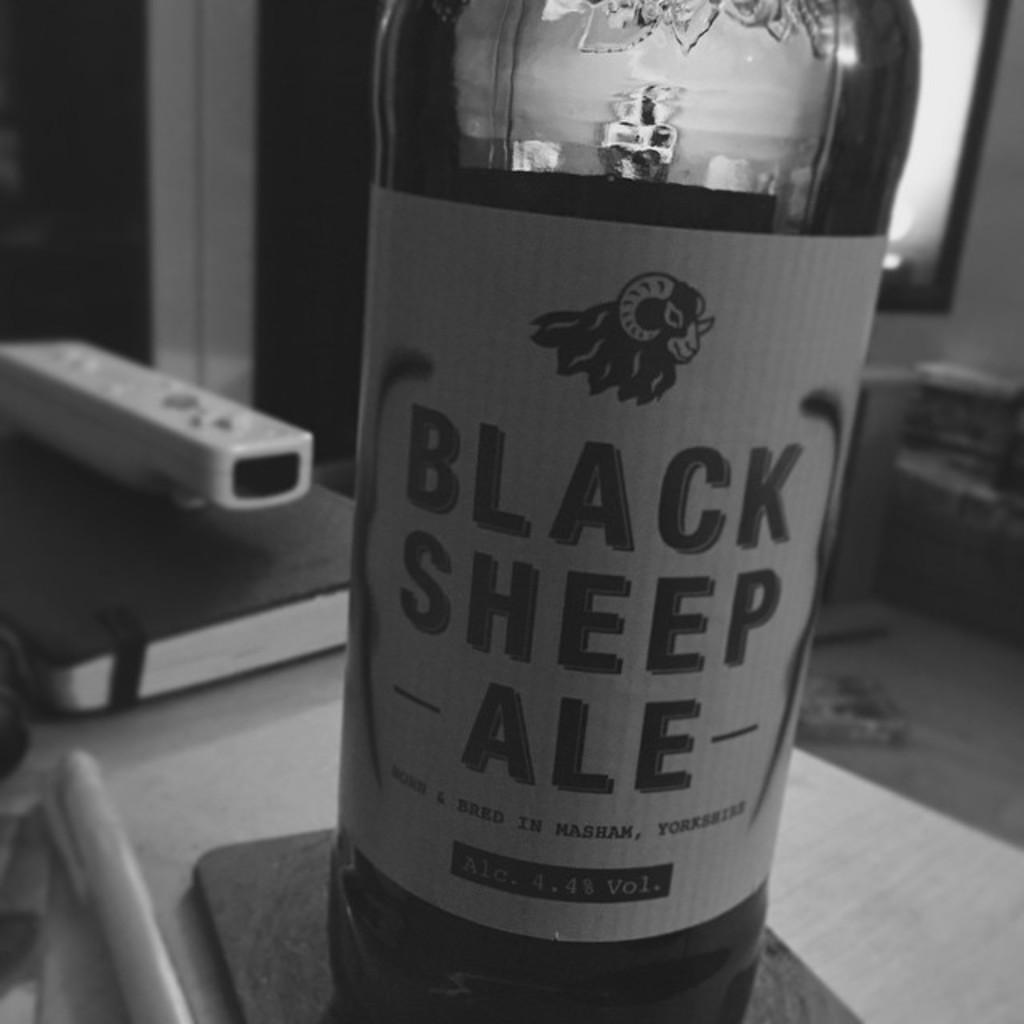<image>
Summarize the visual content of the image. A bottle of Black Sheep ale sitting on a coaster. 